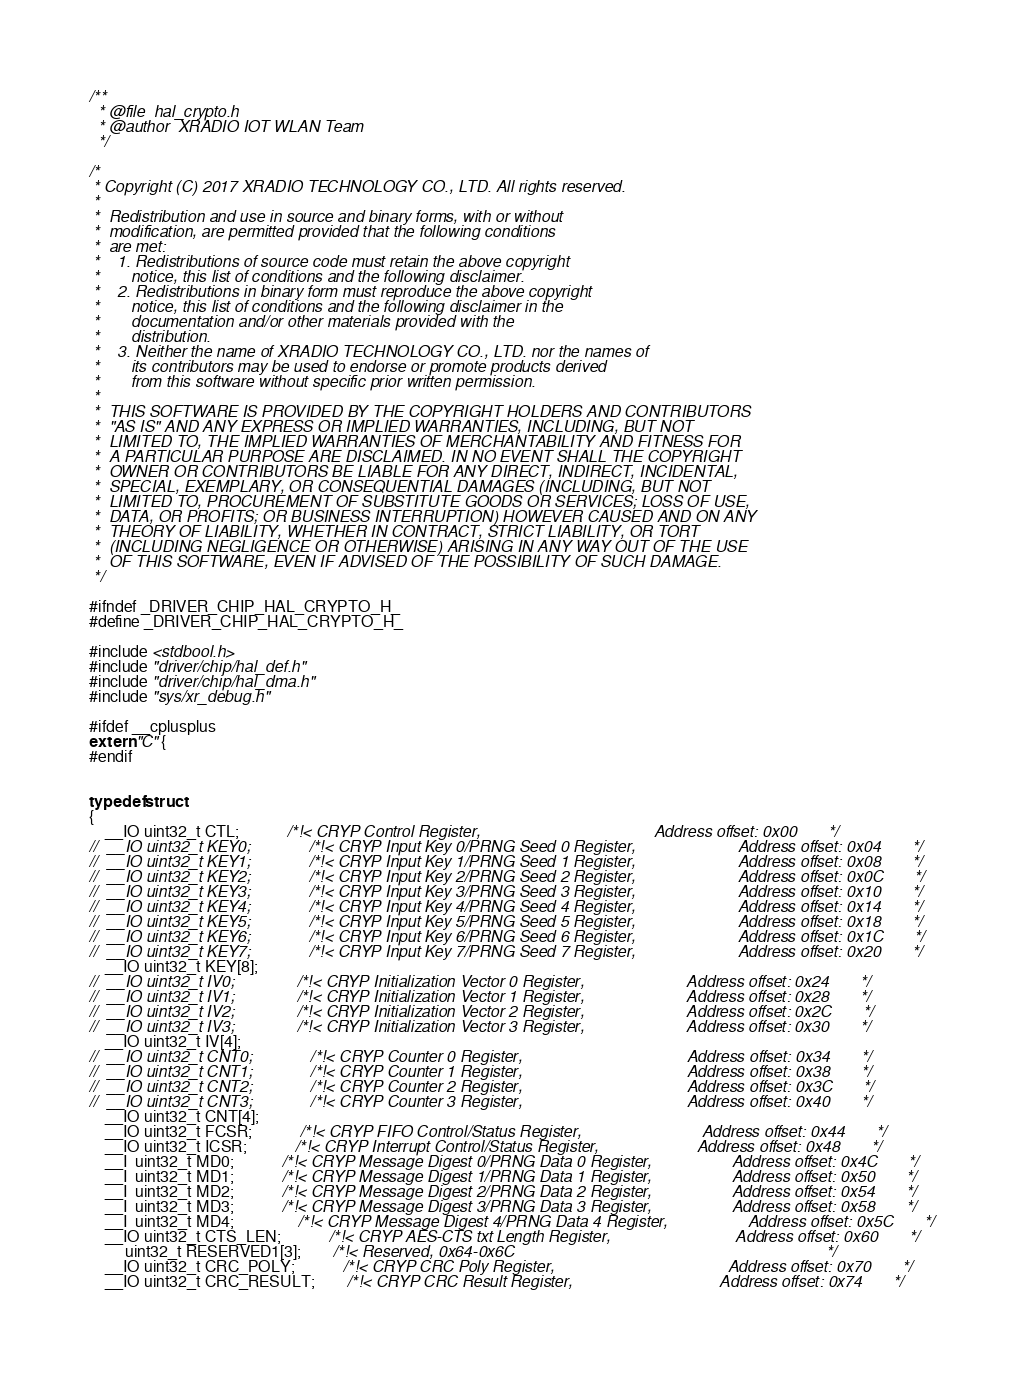Convert code to text. <code><loc_0><loc_0><loc_500><loc_500><_C_>/**
  * @file  hal_crypto.h
  * @author  XRADIO IOT WLAN Team
  */

/*
 * Copyright (C) 2017 XRADIO TECHNOLOGY CO., LTD. All rights reserved.
 *
 *  Redistribution and use in source and binary forms, with or without
 *  modification, are permitted provided that the following conditions
 *  are met:
 *    1. Redistributions of source code must retain the above copyright
 *       notice, this list of conditions and the following disclaimer.
 *    2. Redistributions in binary form must reproduce the above copyright
 *       notice, this list of conditions and the following disclaimer in the
 *       documentation and/or other materials provided with the
 *       distribution.
 *    3. Neither the name of XRADIO TECHNOLOGY CO., LTD. nor the names of
 *       its contributors may be used to endorse or promote products derived
 *       from this software without specific prior written permission.
 *
 *  THIS SOFTWARE IS PROVIDED BY THE COPYRIGHT HOLDERS AND CONTRIBUTORS
 *  "AS IS" AND ANY EXPRESS OR IMPLIED WARRANTIES, INCLUDING, BUT NOT
 *  LIMITED TO, THE IMPLIED WARRANTIES OF MERCHANTABILITY AND FITNESS FOR
 *  A PARTICULAR PURPOSE ARE DISCLAIMED. IN NO EVENT SHALL THE COPYRIGHT
 *  OWNER OR CONTRIBUTORS BE LIABLE FOR ANY DIRECT, INDIRECT, INCIDENTAL,
 *  SPECIAL, EXEMPLARY, OR CONSEQUENTIAL DAMAGES (INCLUDING, BUT NOT
 *  LIMITED TO, PROCUREMENT OF SUBSTITUTE GOODS OR SERVICES; LOSS OF USE,
 *  DATA, OR PROFITS; OR BUSINESS INTERRUPTION) HOWEVER CAUSED AND ON ANY
 *  THEORY OF LIABILITY, WHETHER IN CONTRACT, STRICT LIABILITY, OR TORT
 *  (INCLUDING NEGLIGENCE OR OTHERWISE) ARISING IN ANY WAY OUT OF THE USE
 *  OF THIS SOFTWARE, EVEN IF ADVISED OF THE POSSIBILITY OF SUCH DAMAGE.
 */

#ifndef _DRIVER_CHIP_HAL_CRYPTO_H_
#define _DRIVER_CHIP_HAL_CRYPTO_H_

#include <stdbool.h>
#include "driver/chip/hal_def.h"
#include "driver/chip/hal_dma.h"
#include "sys/xr_debug.h"

#ifdef __cplusplus
extern "C" {
#endif


typedef struct
{
	__IO uint32_t CTL;   			/*!< CRYP Control Register,                                       Address offset: 0x00       */
//	__IO uint32_t KEY0;  			/*!< CRYP Input Key 0/PRNG Seed 0 Register,                       Address offset: 0x04       */
//	__IO uint32_t KEY1;  			/*!< CRYP Input Key 1/PRNG Seed 1 Register,                       Address offset: 0x08       */
//	__IO uint32_t KEY2;  			/*!< CRYP Input Key 2/PRNG Seed 2 Register,                       Address offset: 0x0C       */
//	__IO uint32_t KEY3;  			/*!< CRYP Input Key 3/PRNG Seed 3 Register,                       Address offset: 0x10       */
//	__IO uint32_t KEY4;  			/*!< CRYP Input Key 4/PRNG Seed 4 Register,                       Address offset: 0x14       */
//	__IO uint32_t KEY5;  			/*!< CRYP Input Key 5/PRNG Seed 5 Register,                       Address offset: 0x18       */
//	__IO uint32_t KEY6;  			/*!< CRYP Input Key 6/PRNG Seed 6 Register,                       Address offset: 0x1C       */
//	__IO uint32_t KEY7;  			/*!< CRYP Input Key 7/PRNG Seed 7 Register,                       Address offset: 0x20       */
	__IO uint32_t KEY[8];
//	__IO uint32_t IV0;   			/*!< CRYP Initialization Vector 0 Register,                       Address offset: 0x24       */
//	__IO uint32_t IV1;   			/*!< CRYP Initialization Vector 1 Register,                       Address offset: 0x28       */
//	__IO uint32_t IV2;   			/*!< CRYP Initialization Vector 2 Register,                       Address offset: 0x2C       */
//	__IO uint32_t IV3;   			/*!< CRYP Initialization Vector 3 Register,                       Address offset: 0x30       */
	__IO uint32_t IV[4];
//	__IO uint32_t CNT0;  			/*!< CRYP Counter 0 Register,                                     Address offset: 0x34       */
//	__IO uint32_t CNT1;  			/*!< CRYP Counter 1 Register,                                     Address offset: 0x38       */
//	__IO uint32_t CNT2;  			/*!< CRYP Counter 2 Register,                                     Address offset: 0x3C       */
//	__IO uint32_t CNT3;  			/*!< CRYP Counter 3 Register,                                     Address offset: 0x40       */
	__IO uint32_t CNT[4];
	__IO uint32_t FCSR;  			/*!< CRYP FIFO Control/Status Register,                           Address offset: 0x44       */
	__IO uint32_t ICSR;  			/*!< CRYP Interrupt Control/Status Register,                      Address offset: 0x48       */
	__I  uint32_t MD0;   			/*!< CRYP Message Digest 0/PRNG Data 0 Register,                  Address offset: 0x4C       */
	__I  uint32_t MD1;   			/*!< CRYP Message Digest 1/PRNG Data 1 Register,                  Address offset: 0x50       */
	__I  uint32_t MD2;   			/*!< CRYP Message Digest 2/PRNG Data 2 Register,                  Address offset: 0x54       */
	__I  uint32_t MD3;   			/*!< CRYP Message Digest 3/PRNG Data 3 Register,                  Address offset: 0x58       */
	__I  uint32_t MD4;				/*!< CRYP Message Digest 4/PRNG Data 4 Register,                  Address offset: 0x5C       */
	__IO uint32_t CTS_LEN;			/*!< CRYP AES-CTS txt Length Register,                            Address offset: 0x60       */
	     uint32_t RESERVED1[3];		/*!< Reserved, 0x64-0x6C															          */
	__IO uint32_t CRC_POLY;			/*!< CRYP CRC Poly Register, 						               Address offset: 0x70       */
	__IO uint32_t CRC_RESULT;		/*!< CRYP CRC Result Register, 						           Address offset: 0x74       */</code> 